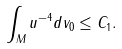<formula> <loc_0><loc_0><loc_500><loc_500>\int _ { M } u ^ { - 4 } d v _ { 0 } \leq C _ { 1 } .</formula> 